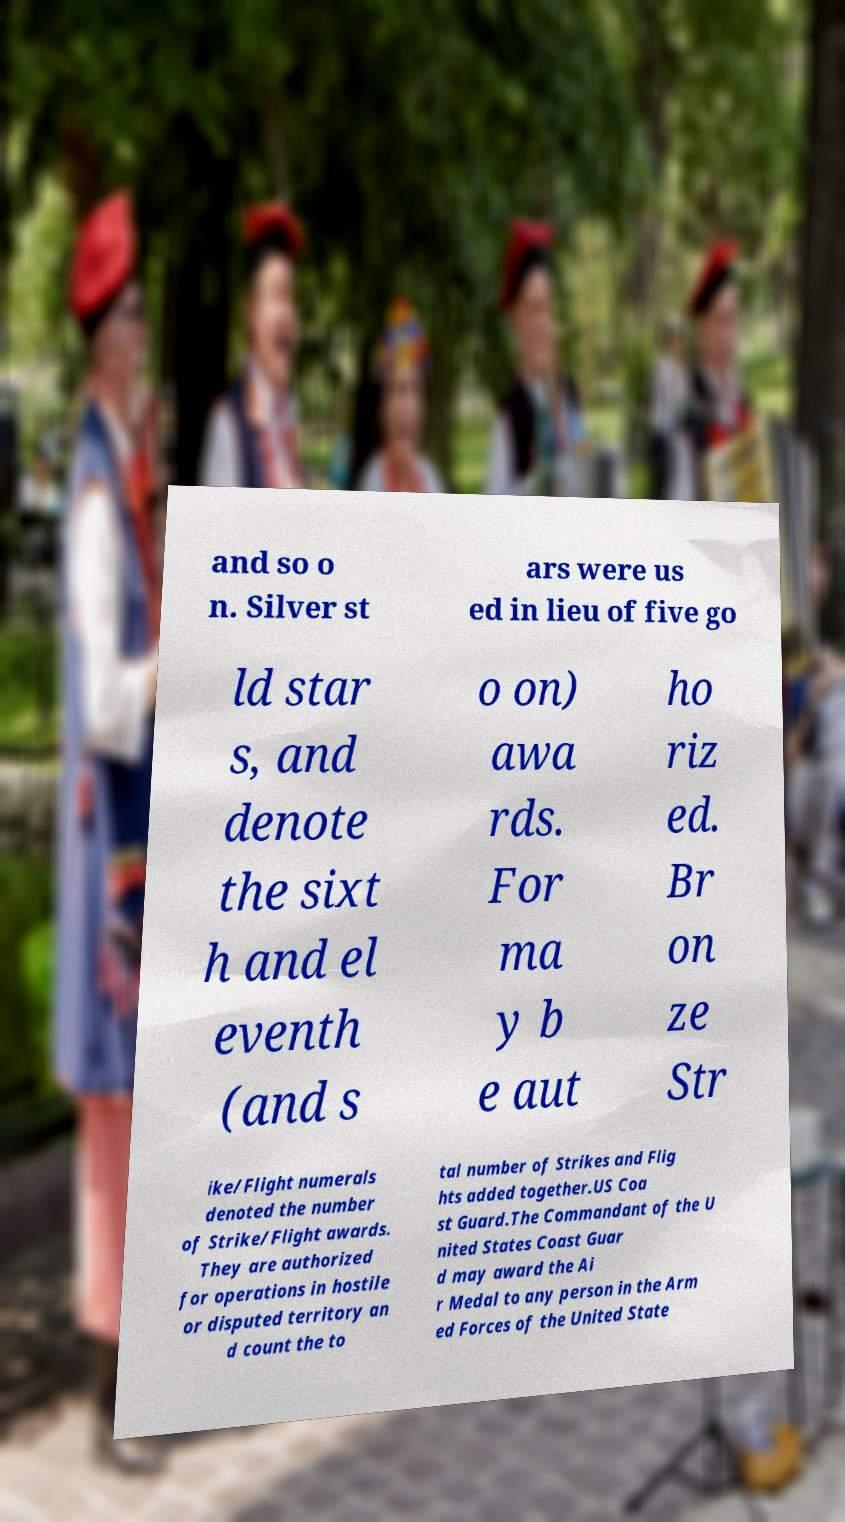Could you assist in decoding the text presented in this image and type it out clearly? and so o n. Silver st ars were us ed in lieu of five go ld star s, and denote the sixt h and el eventh (and s o on) awa rds. For ma y b e aut ho riz ed. Br on ze Str ike/Flight numerals denoted the number of Strike/Flight awards. They are authorized for operations in hostile or disputed territory an d count the to tal number of Strikes and Flig hts added together.US Coa st Guard.The Commandant of the U nited States Coast Guar d may award the Ai r Medal to any person in the Arm ed Forces of the United State 